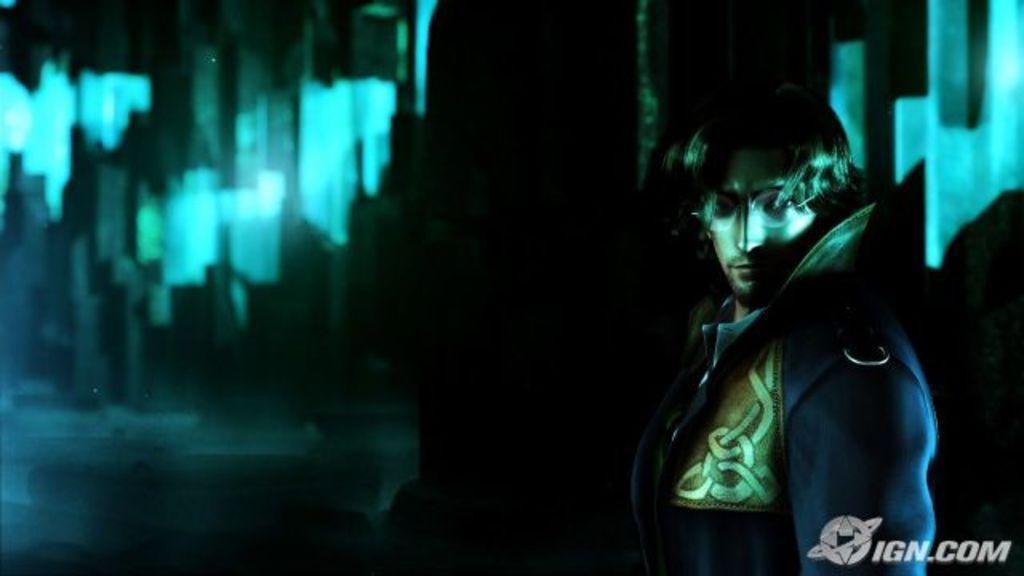How would you summarize this image in a sentence or two? This picture is blurry and dark, in this picture there is a man wore glasses. In the bottom right side of the image we can see text. 